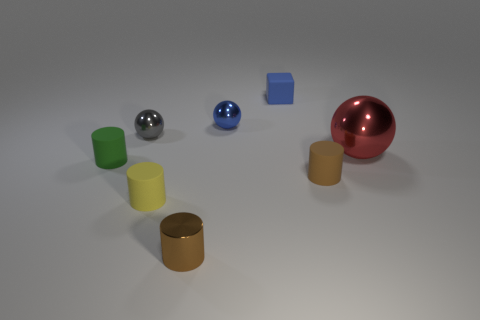Are there fewer blue balls than large cyan matte blocks?
Keep it short and to the point. No. What is the material of the block that is the same size as the yellow cylinder?
Your answer should be compact. Rubber. How many objects are matte cylinders or tiny cylinders?
Offer a terse response. 4. How many objects are behind the brown rubber cylinder and to the right of the blue matte object?
Offer a very short reply. 1. Are there fewer rubber cylinders to the right of the small blue ball than blue metal things?
Your answer should be compact. No. The gray metal object that is the same size as the brown shiny cylinder is what shape?
Provide a succinct answer. Sphere. What number of other objects are the same color as the big metallic object?
Keep it short and to the point. 0. Do the green thing and the gray metal thing have the same size?
Your answer should be compact. Yes. What number of things are either tiny gray balls or rubber cylinders that are left of the tiny brown metallic object?
Give a very brief answer. 3. Are there fewer tiny gray metallic objects left of the small gray metal ball than big red shiny spheres in front of the tiny yellow cylinder?
Keep it short and to the point. No. 